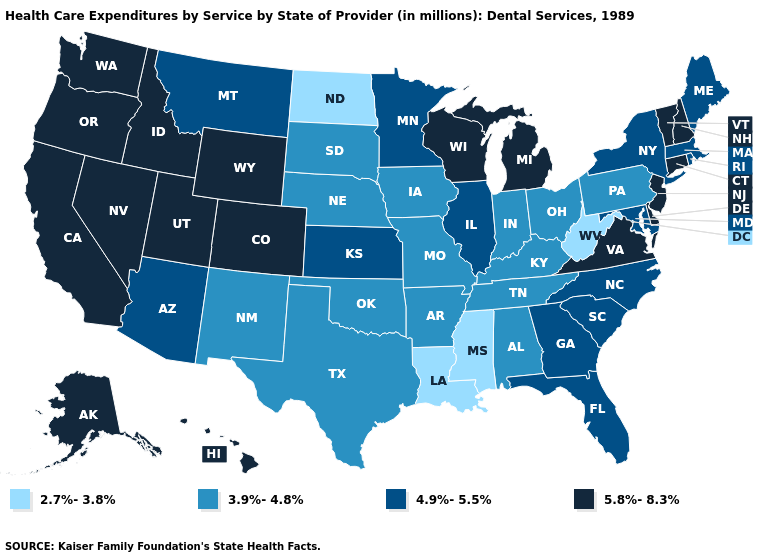Name the states that have a value in the range 4.9%-5.5%?
Answer briefly. Arizona, Florida, Georgia, Illinois, Kansas, Maine, Maryland, Massachusetts, Minnesota, Montana, New York, North Carolina, Rhode Island, South Carolina. What is the value of Nevada?
Be succinct. 5.8%-8.3%. Does Maine have a lower value than New Hampshire?
Short answer required. Yes. What is the highest value in states that border Oregon?
Short answer required. 5.8%-8.3%. How many symbols are there in the legend?
Give a very brief answer. 4. What is the value of Maryland?
Keep it brief. 4.9%-5.5%. Does Utah have the highest value in the West?
Be succinct. Yes. Does Pennsylvania have the lowest value in the Northeast?
Give a very brief answer. Yes. Name the states that have a value in the range 2.7%-3.8%?
Concise answer only. Louisiana, Mississippi, North Dakota, West Virginia. Does Louisiana have the highest value in the South?
Short answer required. No. What is the value of Delaware?
Answer briefly. 5.8%-8.3%. Does Connecticut have the highest value in the Northeast?
Short answer required. Yes. Name the states that have a value in the range 2.7%-3.8%?
Give a very brief answer. Louisiana, Mississippi, North Dakota, West Virginia. What is the lowest value in states that border Delaware?
Be succinct. 3.9%-4.8%. Does Pennsylvania have the highest value in the USA?
Keep it brief. No. 